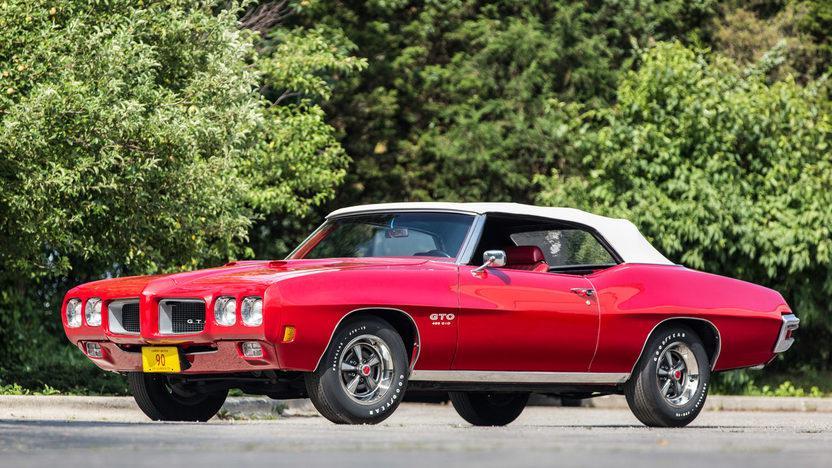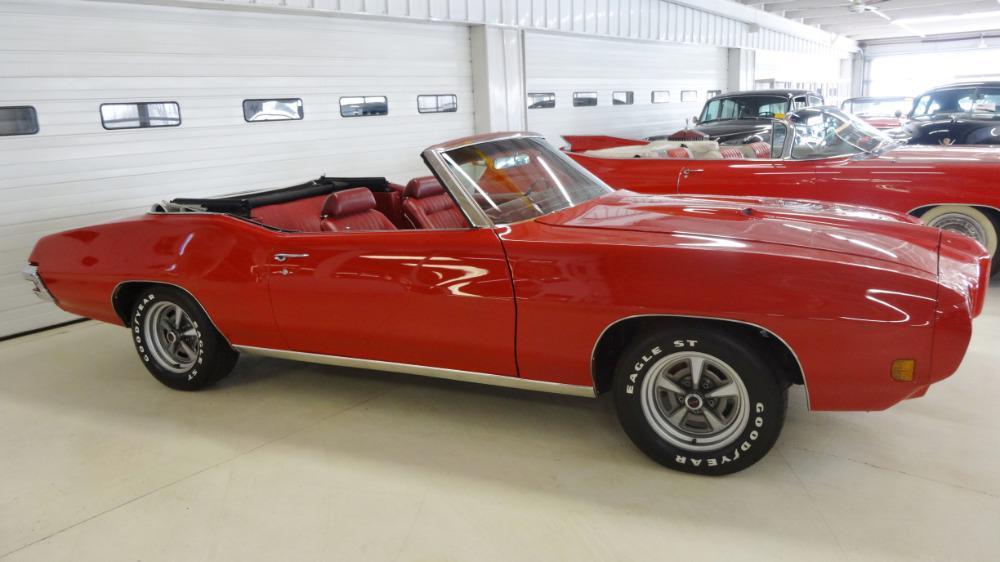The first image is the image on the left, the second image is the image on the right. For the images shown, is this caption "At least one car has its top down." true? Answer yes or no. Yes. 